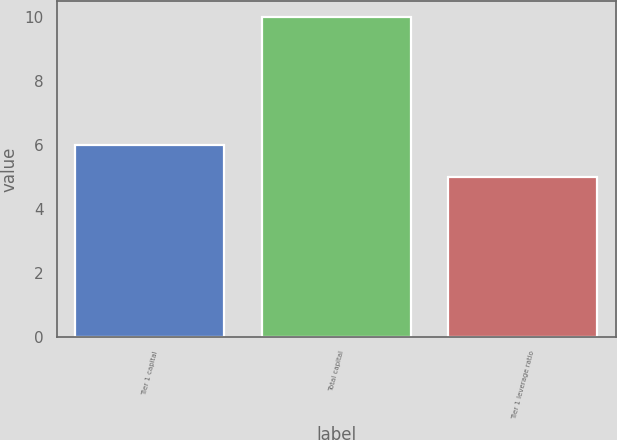<chart> <loc_0><loc_0><loc_500><loc_500><bar_chart><fcel>Tier 1 capital<fcel>Total capital<fcel>Tier 1 leverage ratio<nl><fcel>6<fcel>10<fcel>5<nl></chart> 